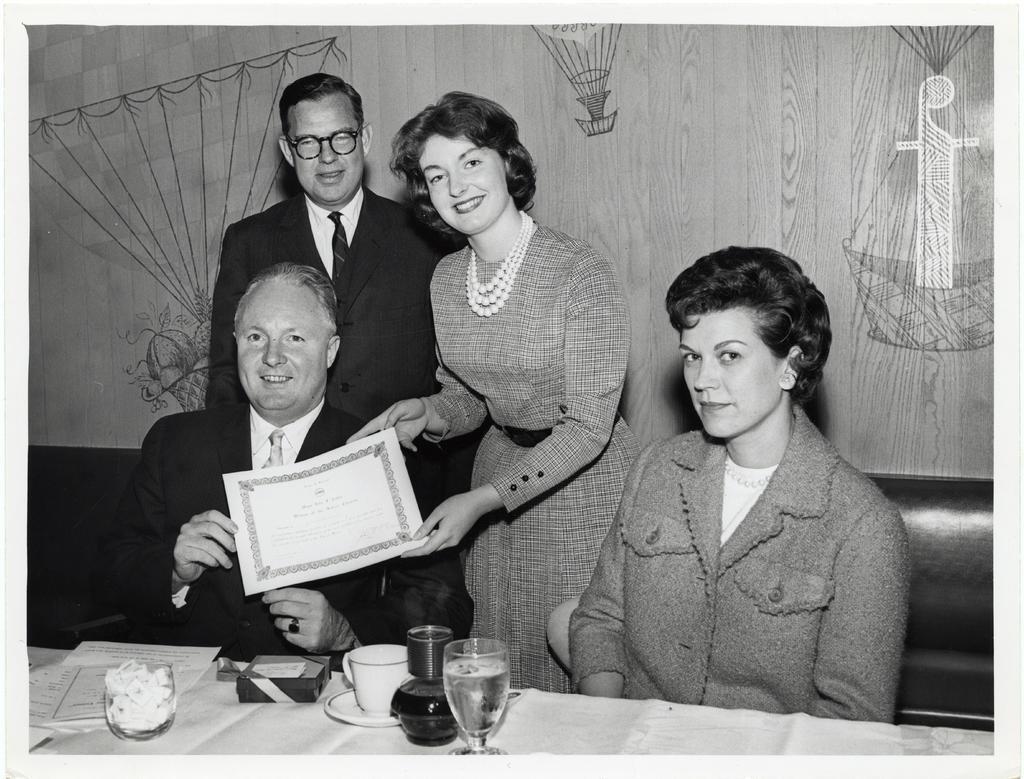How would you summarize this image in a sentence or two? In this picture we can see a man and a woman holding a certificate and smiling. There is another woman sitting on the chair. We can see a person standing at the back. There is a cup, saucer, glass , papers and other objects on the table. We can see some painting on the wall in the background. 